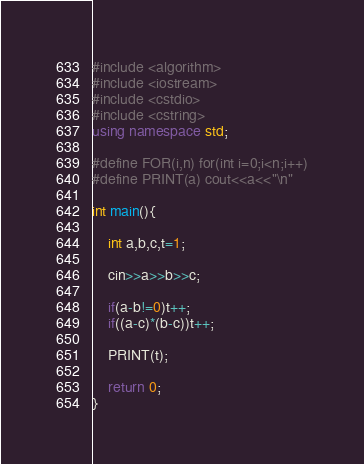<code> <loc_0><loc_0><loc_500><loc_500><_C++_>#include <algorithm>
#include <iostream>
#include <cstdio>
#include <cstring>
using namespace std;

#define FOR(i,n) for(int i=0;i<n;i++)
#define PRINT(a) cout<<a<<"\n"
 
int main(){

	int a,b,c,t=1;

	cin>>a>>b>>c;

	if(a-b!=0)t++;
	if((a-c)*(b-c))t++;

	PRINT(t);

	return 0;
}</code> 